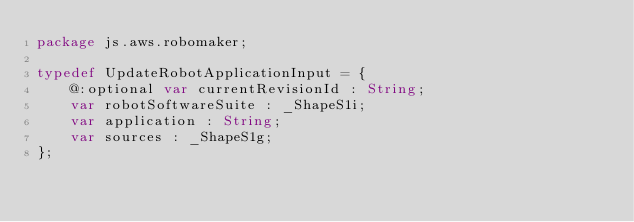Convert code to text. <code><loc_0><loc_0><loc_500><loc_500><_Haxe_>package js.aws.robomaker;

typedef UpdateRobotApplicationInput = {
    @:optional var currentRevisionId : String;
    var robotSoftwareSuite : _ShapeS1i;
    var application : String;
    var sources : _ShapeS1g;
};
</code> 